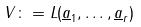Convert formula to latex. <formula><loc_0><loc_0><loc_500><loc_500>V \colon = L ( \underline { a } _ { 1 } , \dots , \underline { a } _ { r } )</formula> 